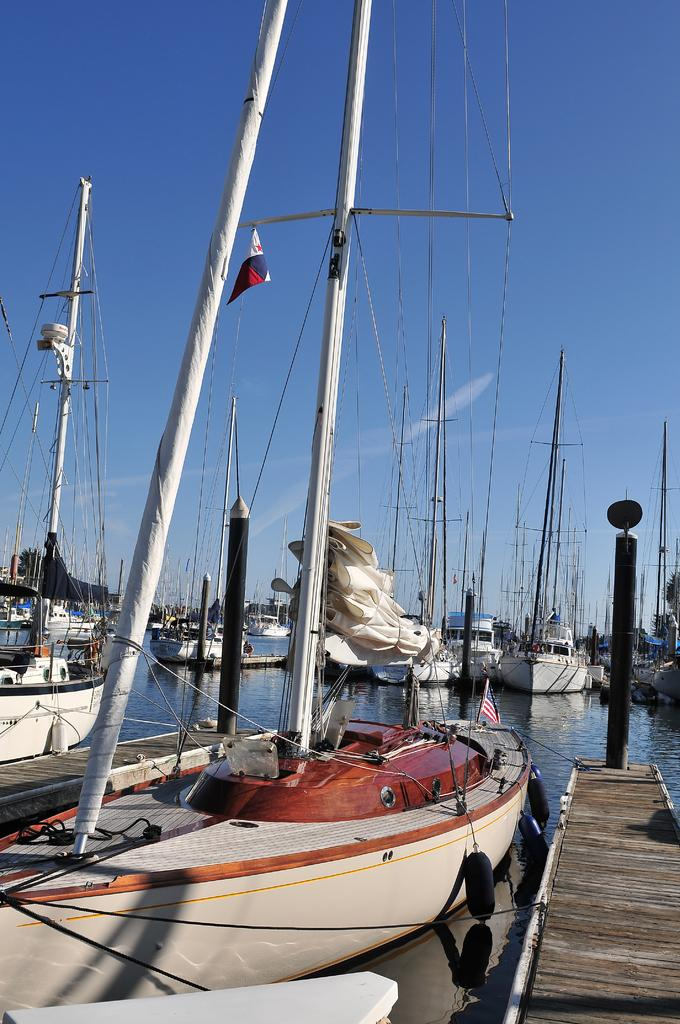What is the main subject in the center of the image? There are boats in the center of the image. What features do the boats have? The boats have poles and ropes. What can be seen on the right side of the image? There is a ramp on the right side of the image. What is the color of the pole on the right side of the image? There is a black color pole on the right side of the image. What type of advertisement is displayed on the boats in the image? There is no advertisement displayed on the boats in the image; the boats have poles and ropes, but no advertisements are visible. 